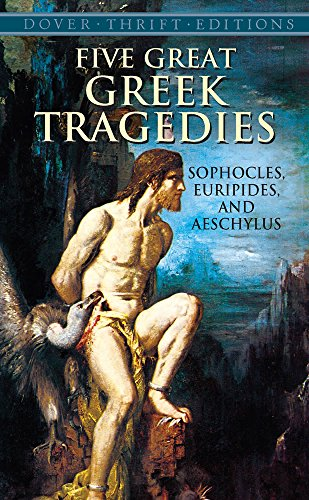What type of book is this? This is a compilation of classical literature, specifically comprising important Greek tragedies that have significantly influenced the field of literature and drama. 